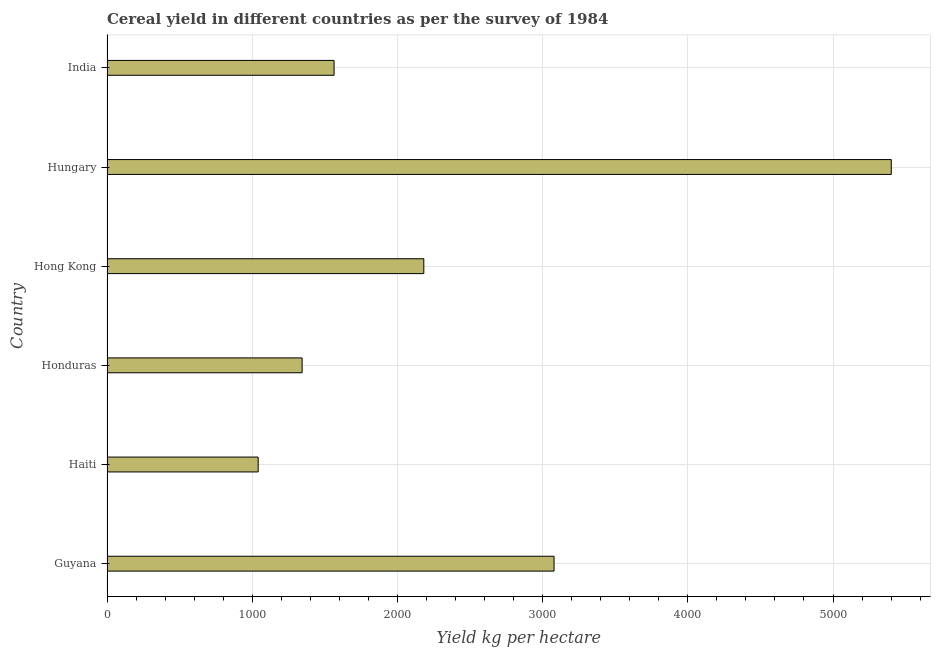What is the title of the graph?
Provide a succinct answer. Cereal yield in different countries as per the survey of 1984. What is the label or title of the X-axis?
Provide a succinct answer. Yield kg per hectare. What is the label or title of the Y-axis?
Your response must be concise. Country. What is the cereal yield in Haiti?
Offer a terse response. 1041.1. Across all countries, what is the maximum cereal yield?
Keep it short and to the point. 5401.16. Across all countries, what is the minimum cereal yield?
Provide a short and direct response. 1041.1. In which country was the cereal yield maximum?
Your answer should be compact. Hungary. In which country was the cereal yield minimum?
Give a very brief answer. Haiti. What is the sum of the cereal yield?
Your answer should be very brief. 1.46e+04. What is the difference between the cereal yield in Guyana and Haiti?
Provide a succinct answer. 2037.61. What is the average cereal yield per country?
Your answer should be very brief. 2435.07. What is the median cereal yield?
Offer a very short reply. 1872.83. In how many countries, is the cereal yield greater than 4000 kg per hectare?
Offer a very short reply. 1. What is the ratio of the cereal yield in Honduras to that in Hungary?
Offer a terse response. 0.25. Is the cereal yield in Guyana less than that in Honduras?
Offer a very short reply. No. What is the difference between the highest and the second highest cereal yield?
Offer a very short reply. 2322.44. Is the sum of the cereal yield in Guyana and Honduras greater than the maximum cereal yield across all countries?
Give a very brief answer. No. What is the difference between the highest and the lowest cereal yield?
Offer a terse response. 4360.06. In how many countries, is the cereal yield greater than the average cereal yield taken over all countries?
Offer a very short reply. 2. Are all the bars in the graph horizontal?
Make the answer very short. Yes. How many countries are there in the graph?
Keep it short and to the point. 6. What is the difference between two consecutive major ticks on the X-axis?
Ensure brevity in your answer.  1000. Are the values on the major ticks of X-axis written in scientific E-notation?
Your answer should be very brief. No. What is the Yield kg per hectare in Guyana?
Provide a succinct answer. 3078.72. What is the Yield kg per hectare of Haiti?
Your response must be concise. 1041.1. What is the Yield kg per hectare of Honduras?
Your answer should be compact. 1343.79. What is the Yield kg per hectare of Hong Kong?
Your response must be concise. 2181.82. What is the Yield kg per hectare of Hungary?
Provide a succinct answer. 5401.16. What is the Yield kg per hectare in India?
Keep it short and to the point. 1563.84. What is the difference between the Yield kg per hectare in Guyana and Haiti?
Your answer should be very brief. 2037.61. What is the difference between the Yield kg per hectare in Guyana and Honduras?
Keep it short and to the point. 1734.92. What is the difference between the Yield kg per hectare in Guyana and Hong Kong?
Make the answer very short. 896.9. What is the difference between the Yield kg per hectare in Guyana and Hungary?
Give a very brief answer. -2322.44. What is the difference between the Yield kg per hectare in Guyana and India?
Provide a succinct answer. 1514.88. What is the difference between the Yield kg per hectare in Haiti and Honduras?
Give a very brief answer. -302.69. What is the difference between the Yield kg per hectare in Haiti and Hong Kong?
Give a very brief answer. -1140.71. What is the difference between the Yield kg per hectare in Haiti and Hungary?
Ensure brevity in your answer.  -4360.06. What is the difference between the Yield kg per hectare in Haiti and India?
Offer a very short reply. -522.73. What is the difference between the Yield kg per hectare in Honduras and Hong Kong?
Offer a very short reply. -838.03. What is the difference between the Yield kg per hectare in Honduras and Hungary?
Your response must be concise. -4057.37. What is the difference between the Yield kg per hectare in Honduras and India?
Offer a terse response. -220.05. What is the difference between the Yield kg per hectare in Hong Kong and Hungary?
Offer a very short reply. -3219.34. What is the difference between the Yield kg per hectare in Hong Kong and India?
Your response must be concise. 617.98. What is the difference between the Yield kg per hectare in Hungary and India?
Offer a very short reply. 3837.32. What is the ratio of the Yield kg per hectare in Guyana to that in Haiti?
Offer a very short reply. 2.96. What is the ratio of the Yield kg per hectare in Guyana to that in Honduras?
Give a very brief answer. 2.29. What is the ratio of the Yield kg per hectare in Guyana to that in Hong Kong?
Ensure brevity in your answer.  1.41. What is the ratio of the Yield kg per hectare in Guyana to that in Hungary?
Ensure brevity in your answer.  0.57. What is the ratio of the Yield kg per hectare in Guyana to that in India?
Your response must be concise. 1.97. What is the ratio of the Yield kg per hectare in Haiti to that in Honduras?
Provide a succinct answer. 0.78. What is the ratio of the Yield kg per hectare in Haiti to that in Hong Kong?
Provide a succinct answer. 0.48. What is the ratio of the Yield kg per hectare in Haiti to that in Hungary?
Make the answer very short. 0.19. What is the ratio of the Yield kg per hectare in Haiti to that in India?
Provide a short and direct response. 0.67. What is the ratio of the Yield kg per hectare in Honduras to that in Hong Kong?
Give a very brief answer. 0.62. What is the ratio of the Yield kg per hectare in Honduras to that in Hungary?
Provide a short and direct response. 0.25. What is the ratio of the Yield kg per hectare in Honduras to that in India?
Offer a terse response. 0.86. What is the ratio of the Yield kg per hectare in Hong Kong to that in Hungary?
Your answer should be compact. 0.4. What is the ratio of the Yield kg per hectare in Hong Kong to that in India?
Offer a terse response. 1.4. What is the ratio of the Yield kg per hectare in Hungary to that in India?
Keep it short and to the point. 3.45. 